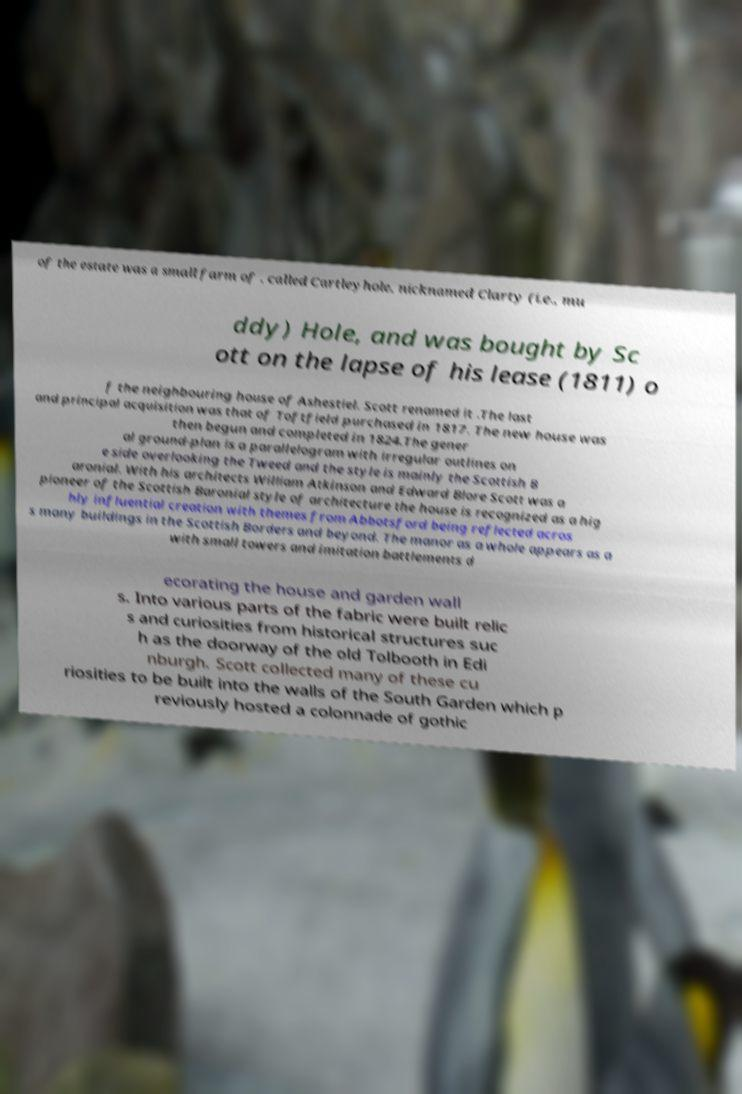Please identify and transcribe the text found in this image. of the estate was a small farm of , called Cartleyhole, nicknamed Clarty (i.e., mu ddy) Hole, and was bought by Sc ott on the lapse of his lease (1811) o f the neighbouring house of Ashestiel. Scott renamed it .The last and principal acquisition was that of Toftfield purchased in 1817. The new house was then begun and completed in 1824.The gener al ground-plan is a parallelogram with irregular outlines on e side overlooking the Tweed and the style is mainly the Scottish B aronial. With his architects William Atkinson and Edward Blore Scott was a pioneer of the Scottish Baronial style of architecture the house is recognized as a hig hly influential creation with themes from Abbotsford being reflected acros s many buildings in the Scottish Borders and beyond. The manor as a whole appears as a with small towers and imitation battlements d ecorating the house and garden wall s. Into various parts of the fabric were built relic s and curiosities from historical structures suc h as the doorway of the old Tolbooth in Edi nburgh. Scott collected many of these cu riosities to be built into the walls of the South Garden which p reviously hosted a colonnade of gothic 